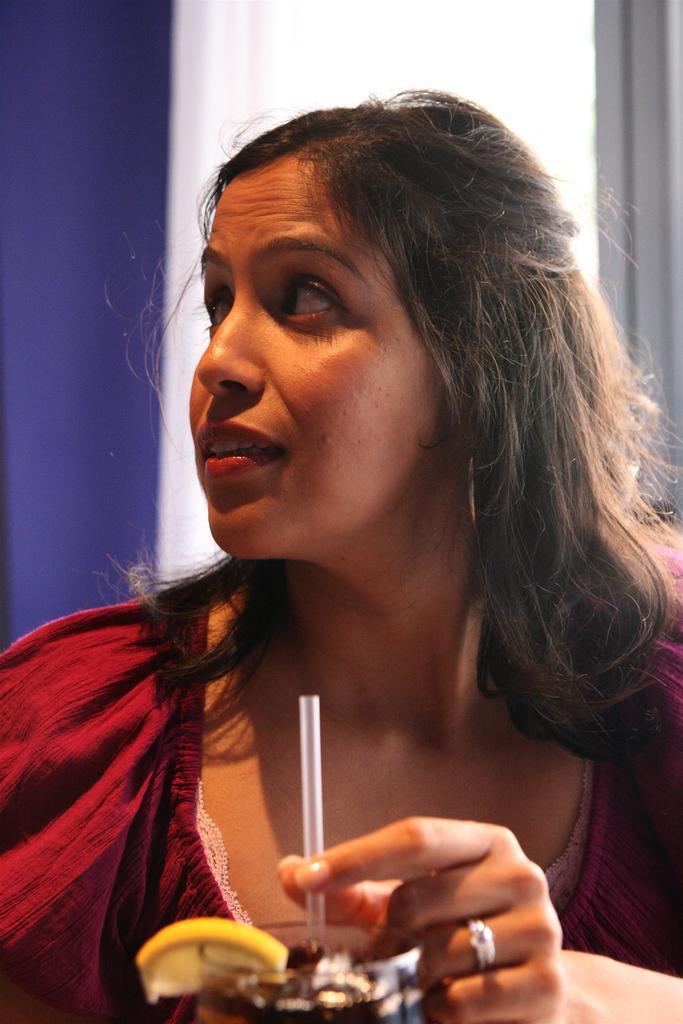Please provide a concise description of this image. In the picture we can see a woman sitting and holding a straw in the ice cream and she is wearing a red color dress and looking to the side and in the background, we can see a curtain which is white in color and a wall which is blue in color. 